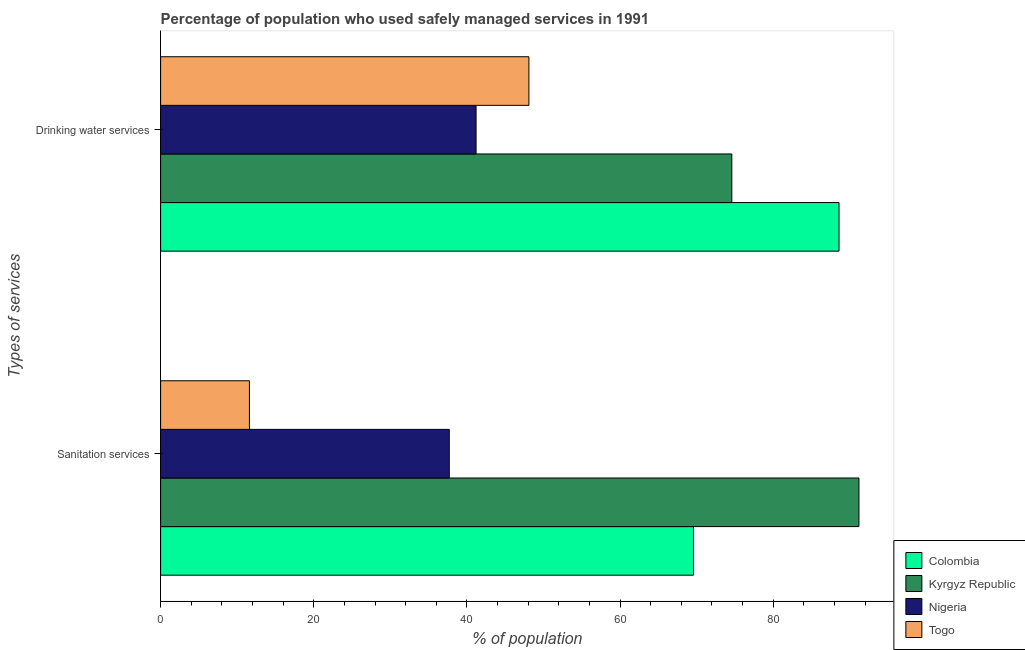How many groups of bars are there?
Provide a short and direct response. 2. Are the number of bars per tick equal to the number of legend labels?
Give a very brief answer. Yes. Are the number of bars on each tick of the Y-axis equal?
Your answer should be very brief. Yes. What is the label of the 2nd group of bars from the top?
Provide a succinct answer. Sanitation services. What is the percentage of population who used drinking water services in Colombia?
Provide a succinct answer. 88.6. Across all countries, what is the maximum percentage of population who used drinking water services?
Offer a very short reply. 88.6. Across all countries, what is the minimum percentage of population who used sanitation services?
Your answer should be very brief. 11.6. In which country was the percentage of population who used drinking water services maximum?
Ensure brevity in your answer.  Colombia. In which country was the percentage of population who used sanitation services minimum?
Provide a short and direct response. Togo. What is the total percentage of population who used sanitation services in the graph?
Provide a succinct answer. 210.1. What is the difference between the percentage of population who used sanitation services in Nigeria and that in Togo?
Make the answer very short. 26.1. What is the difference between the percentage of population who used sanitation services in Nigeria and the percentage of population who used drinking water services in Togo?
Keep it short and to the point. -10.4. What is the average percentage of population who used drinking water services per country?
Offer a terse response. 63.12. What is the ratio of the percentage of population who used drinking water services in Colombia to that in Nigeria?
Make the answer very short. 2.15. Is the percentage of population who used sanitation services in Togo less than that in Nigeria?
Provide a succinct answer. Yes. What does the 2nd bar from the top in Drinking water services represents?
Provide a succinct answer. Nigeria. What does the 1st bar from the bottom in Drinking water services represents?
Make the answer very short. Colombia. Are the values on the major ticks of X-axis written in scientific E-notation?
Your answer should be compact. No. Does the graph contain any zero values?
Give a very brief answer. No. Does the graph contain grids?
Your response must be concise. No. How many legend labels are there?
Provide a succinct answer. 4. What is the title of the graph?
Make the answer very short. Percentage of population who used safely managed services in 1991. What is the label or title of the X-axis?
Offer a very short reply. % of population. What is the label or title of the Y-axis?
Your answer should be very brief. Types of services. What is the % of population of Colombia in Sanitation services?
Your answer should be compact. 69.6. What is the % of population in Kyrgyz Republic in Sanitation services?
Offer a terse response. 91.2. What is the % of population in Nigeria in Sanitation services?
Provide a succinct answer. 37.7. What is the % of population in Colombia in Drinking water services?
Your response must be concise. 88.6. What is the % of population of Kyrgyz Republic in Drinking water services?
Offer a terse response. 74.6. What is the % of population of Nigeria in Drinking water services?
Make the answer very short. 41.2. What is the % of population in Togo in Drinking water services?
Provide a succinct answer. 48.1. Across all Types of services, what is the maximum % of population in Colombia?
Make the answer very short. 88.6. Across all Types of services, what is the maximum % of population of Kyrgyz Republic?
Provide a short and direct response. 91.2. Across all Types of services, what is the maximum % of population in Nigeria?
Your response must be concise. 41.2. Across all Types of services, what is the maximum % of population in Togo?
Provide a succinct answer. 48.1. Across all Types of services, what is the minimum % of population in Colombia?
Provide a succinct answer. 69.6. Across all Types of services, what is the minimum % of population in Kyrgyz Republic?
Ensure brevity in your answer.  74.6. Across all Types of services, what is the minimum % of population in Nigeria?
Your answer should be very brief. 37.7. Across all Types of services, what is the minimum % of population in Togo?
Provide a succinct answer. 11.6. What is the total % of population in Colombia in the graph?
Provide a succinct answer. 158.2. What is the total % of population in Kyrgyz Republic in the graph?
Offer a terse response. 165.8. What is the total % of population of Nigeria in the graph?
Ensure brevity in your answer.  78.9. What is the total % of population in Togo in the graph?
Your answer should be compact. 59.7. What is the difference between the % of population in Kyrgyz Republic in Sanitation services and that in Drinking water services?
Keep it short and to the point. 16.6. What is the difference between the % of population in Togo in Sanitation services and that in Drinking water services?
Your answer should be very brief. -36.5. What is the difference between the % of population in Colombia in Sanitation services and the % of population in Kyrgyz Republic in Drinking water services?
Your answer should be compact. -5. What is the difference between the % of population in Colombia in Sanitation services and the % of population in Nigeria in Drinking water services?
Give a very brief answer. 28.4. What is the difference between the % of population in Colombia in Sanitation services and the % of population in Togo in Drinking water services?
Your answer should be very brief. 21.5. What is the difference between the % of population in Kyrgyz Republic in Sanitation services and the % of population in Nigeria in Drinking water services?
Keep it short and to the point. 50. What is the difference between the % of population in Kyrgyz Republic in Sanitation services and the % of population in Togo in Drinking water services?
Your response must be concise. 43.1. What is the difference between the % of population in Nigeria in Sanitation services and the % of population in Togo in Drinking water services?
Provide a succinct answer. -10.4. What is the average % of population in Colombia per Types of services?
Ensure brevity in your answer.  79.1. What is the average % of population in Kyrgyz Republic per Types of services?
Keep it short and to the point. 82.9. What is the average % of population of Nigeria per Types of services?
Your answer should be compact. 39.45. What is the average % of population in Togo per Types of services?
Your response must be concise. 29.85. What is the difference between the % of population in Colombia and % of population in Kyrgyz Republic in Sanitation services?
Your response must be concise. -21.6. What is the difference between the % of population in Colombia and % of population in Nigeria in Sanitation services?
Offer a very short reply. 31.9. What is the difference between the % of population in Kyrgyz Republic and % of population in Nigeria in Sanitation services?
Offer a terse response. 53.5. What is the difference between the % of population of Kyrgyz Republic and % of population of Togo in Sanitation services?
Provide a short and direct response. 79.6. What is the difference between the % of population of Nigeria and % of population of Togo in Sanitation services?
Your answer should be compact. 26.1. What is the difference between the % of population in Colombia and % of population in Nigeria in Drinking water services?
Your answer should be very brief. 47.4. What is the difference between the % of population of Colombia and % of population of Togo in Drinking water services?
Your response must be concise. 40.5. What is the difference between the % of population in Kyrgyz Republic and % of population in Nigeria in Drinking water services?
Provide a succinct answer. 33.4. What is the difference between the % of population in Kyrgyz Republic and % of population in Togo in Drinking water services?
Offer a terse response. 26.5. What is the ratio of the % of population of Colombia in Sanitation services to that in Drinking water services?
Provide a short and direct response. 0.79. What is the ratio of the % of population in Kyrgyz Republic in Sanitation services to that in Drinking water services?
Offer a very short reply. 1.22. What is the ratio of the % of population in Nigeria in Sanitation services to that in Drinking water services?
Your answer should be compact. 0.92. What is the ratio of the % of population in Togo in Sanitation services to that in Drinking water services?
Ensure brevity in your answer.  0.24. What is the difference between the highest and the second highest % of population of Colombia?
Keep it short and to the point. 19. What is the difference between the highest and the second highest % of population of Kyrgyz Republic?
Your answer should be very brief. 16.6. What is the difference between the highest and the second highest % of population of Nigeria?
Offer a terse response. 3.5. What is the difference between the highest and the second highest % of population in Togo?
Your answer should be compact. 36.5. What is the difference between the highest and the lowest % of population of Colombia?
Your response must be concise. 19. What is the difference between the highest and the lowest % of population of Kyrgyz Republic?
Offer a terse response. 16.6. What is the difference between the highest and the lowest % of population of Togo?
Ensure brevity in your answer.  36.5. 